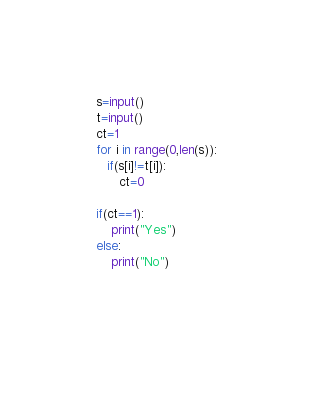Convert code to text. <code><loc_0><loc_0><loc_500><loc_500><_Python_>s=input()
t=input()
ct=1
for i in range(0,len(s)):
   if(s[i]!=t[i]):
      ct=0
      
if(ct==1):
    print("Yes")
else:
    print("No")
                  
                    </code> 